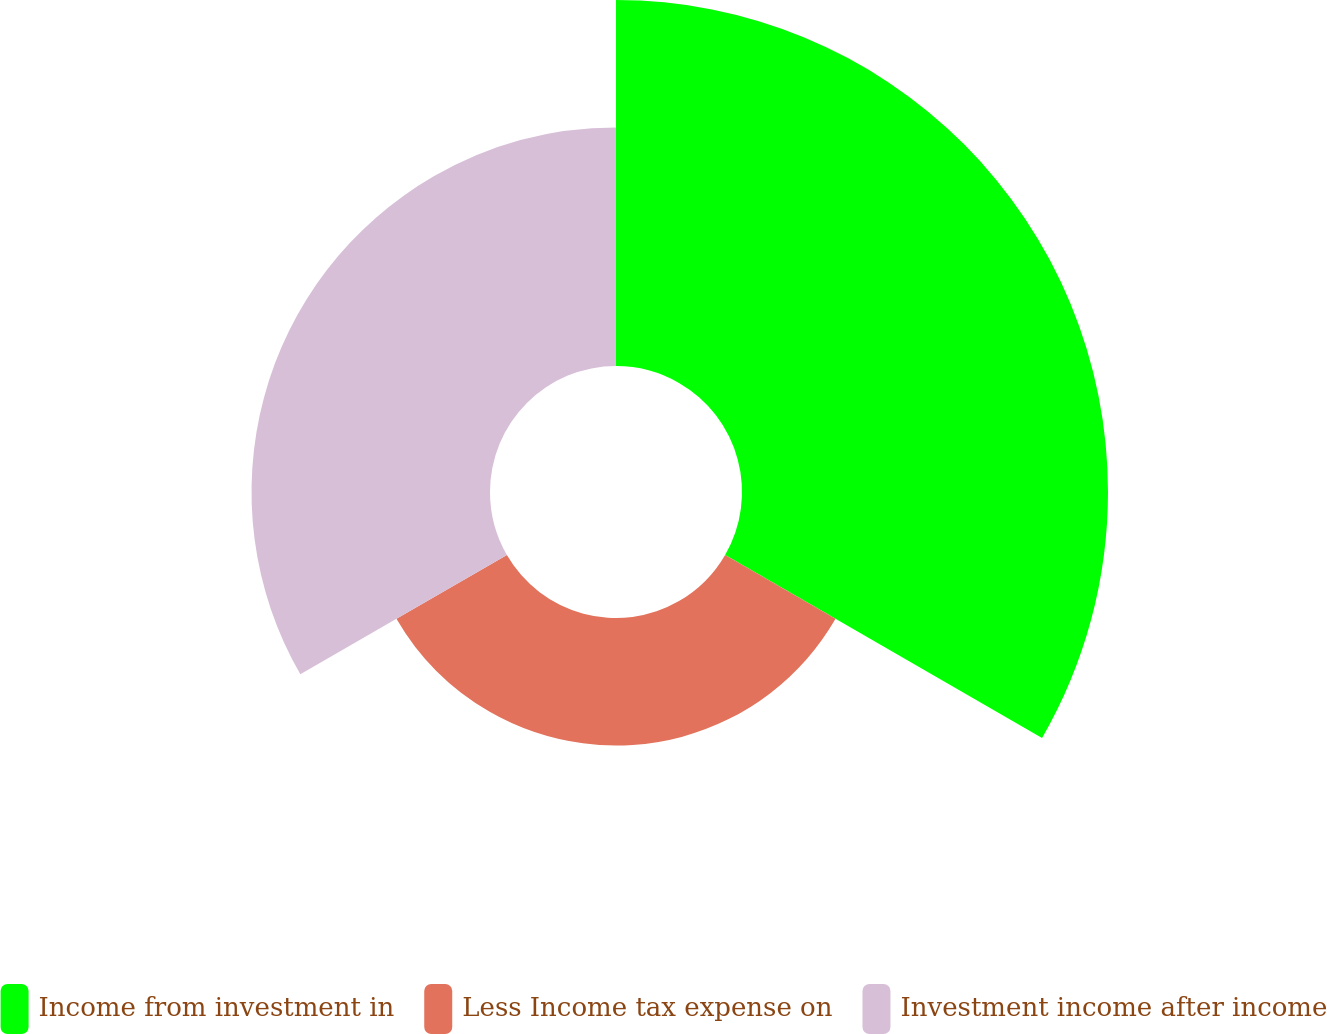Convert chart to OTSL. <chart><loc_0><loc_0><loc_500><loc_500><pie_chart><fcel>Income from investment in<fcel>Less Income tax expense on<fcel>Investment income after income<nl><fcel>50.0%<fcel>17.42%<fcel>32.58%<nl></chart> 